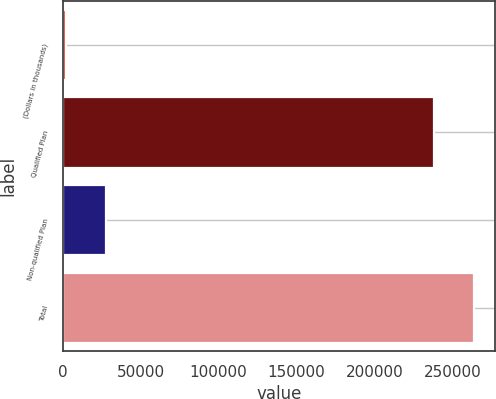<chart> <loc_0><loc_0><loc_500><loc_500><bar_chart><fcel>(Dollars in thousands)<fcel>Qualified Plan<fcel>Non-qualified Plan<fcel>Total<nl><fcel>2018<fcel>237855<fcel>28048.9<fcel>263886<nl></chart> 